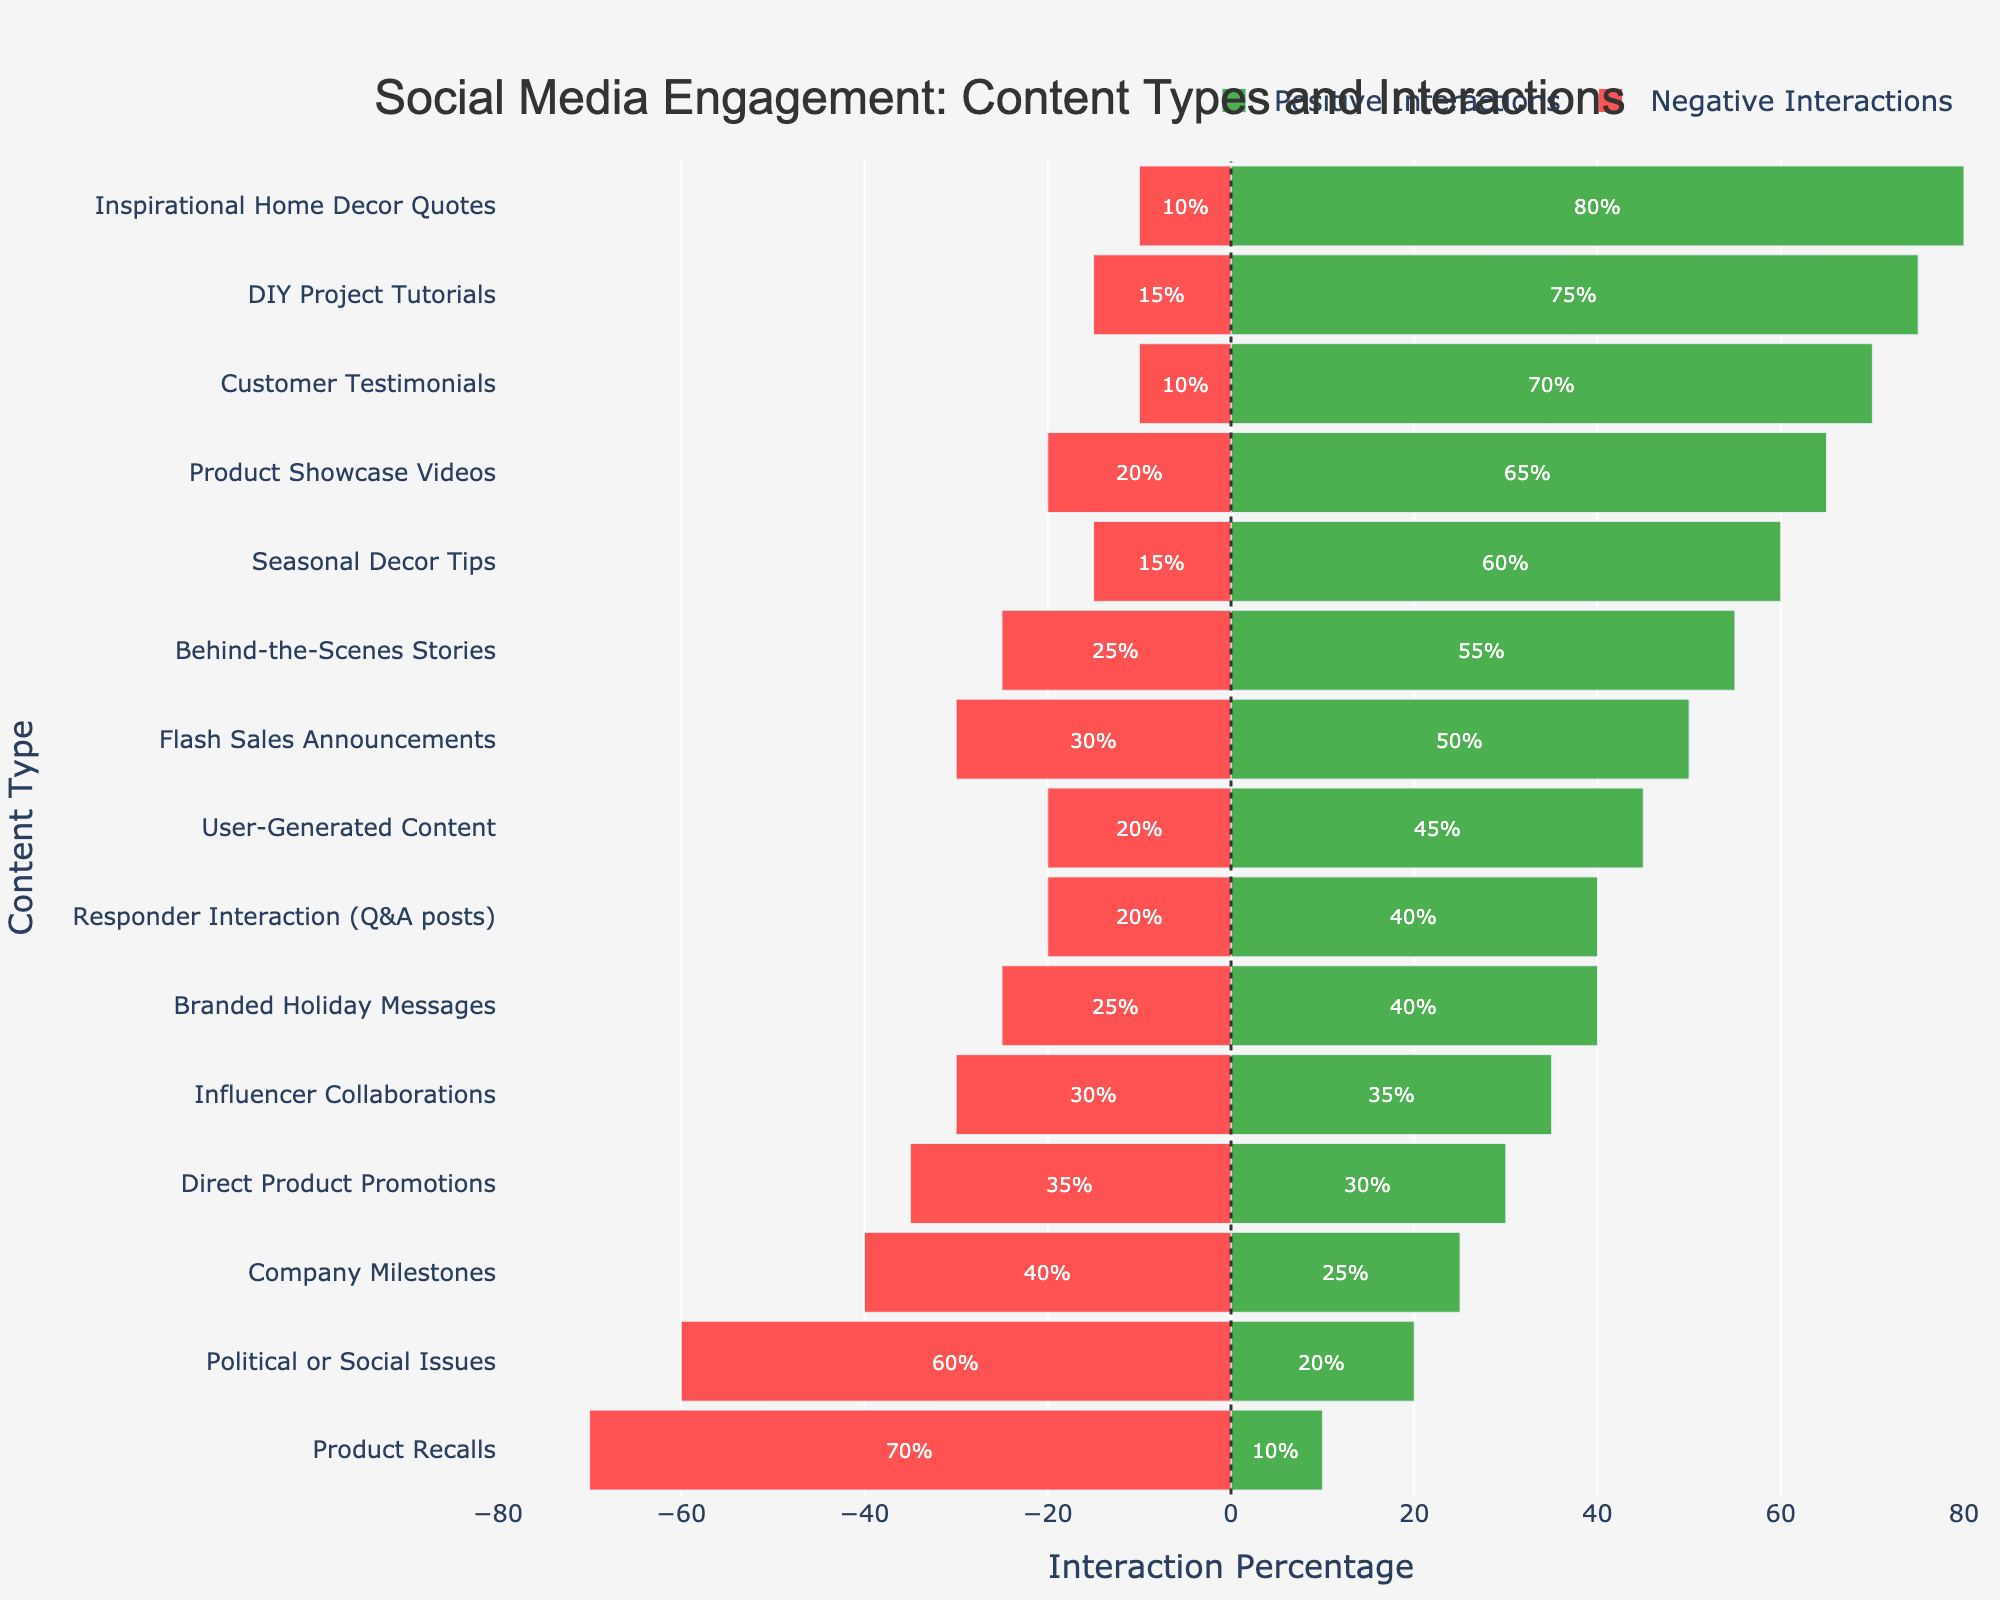What content type received the highest percentage of positive interactions? From the bar chart, look for the highest green bar on the positive side. The tallest bar in this category corresponds to "Inspirational Home Decor Quotes" at 80%.
Answer: Inspirational Home Decor Quotes Which content type received more negative interactions, "Flash Sales Announcements" or "Company Milestones"? Compare the lengths of the red bars for "Flash Sales Announcements" and "Company Milestones." The red bar for "Company Milestones" is longer, indicating 40% negative interactions compared to 30% for "Flash Sales Announcements."
Answer: Company Milestones How much more positive interaction do "DIY Project Tutorials" receive compared to "Direct Product Promotions"? Subtract the positive interaction percentage of "Direct Product Promotions" (30%) from that of "DIY Project Tutorials" (75%): 75% - 30% = 45%.
Answer: 45% What is the average percentage of negative interactions across all content types? Add up all the percentages of negative interactions and divide by the number of content types: (10 + 15 + 10 + 20 + 15 + 25 + 30 + 20 + 25 + 30 + 35 + 40 + 60 + 70 + 20) / 15 = 28.
Answer: 28% Which has greater positive interaction: "User-Generated Content" or "Customer Testimonials"? Look at the green bars for both content types and compare them. "Customer Testimonials" has a positive interaction of 70%, whereas "User-Generated Content" has 45%. Thus, "Customer Testimonials" has a greater positive interaction.
Answer: Customer Testimonials What is the total percentage of interactions (positive and negative) for "Behind-the-Scenes Stories"? Add the positive (55%) and negative (25%) interaction percentages for "Behind-the-Scenes Stories": 55% + 25% = 80%.
Answer: 80% Which content type has the lowest percentage of both negative and positive interactions combined? Examine the combined heights of the bars (both positive and negative) for each content type. "Product Recalls" has the lowest combination with 10% positive and 70% negative, totaling 80%.
Answer: Product Recalls Is there any content type that has more negative interactions than positive interactions? Check each content type's bars to see if the red bar (negative) is longer than the green bar (positive). "Political or Social Issues" and "Product Recalls" have more negative interactions than positive.
Answer: Yes What is the difference in negative interactions between "Inspirational Home Decor Quotes" and "Political or Social Issues"? Subtract the negative interaction percentage of "Inspirational Home Decor Quotes" (10%) from that of "Political or Social Issues" (60%): 60% - 10% = 50%.
Answer: 50% 